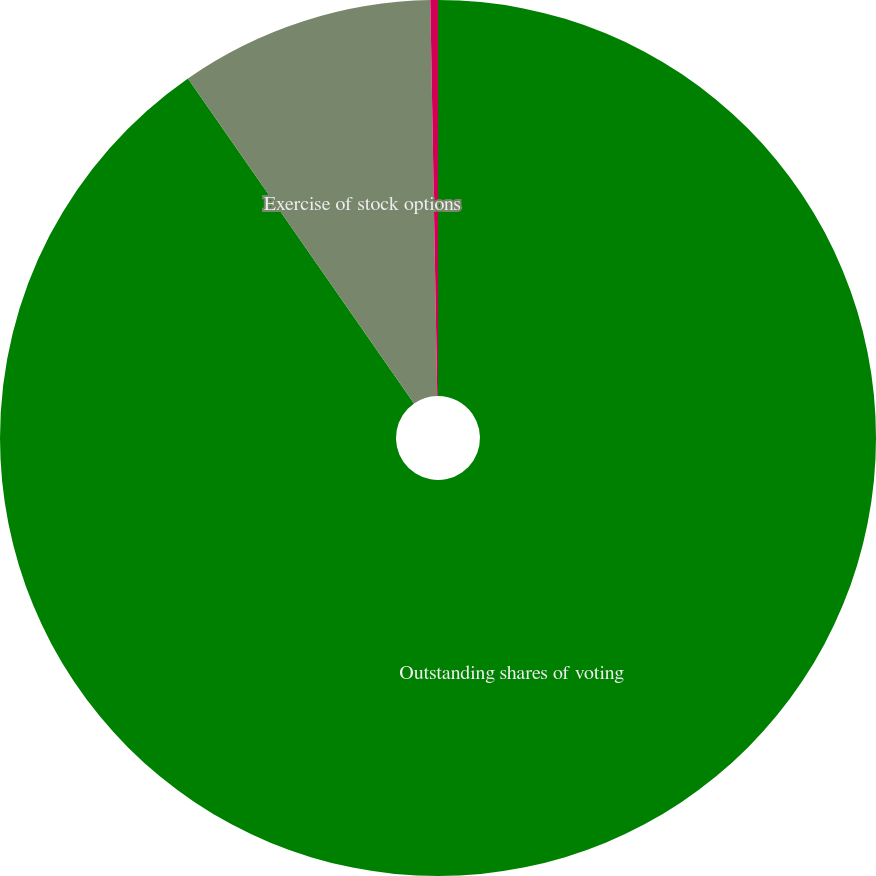Convert chart to OTSL. <chart><loc_0><loc_0><loc_500><loc_500><pie_chart><fcel>Outstanding shares of voting<fcel>Exercise of stock options<fcel>Issuance of restricted stock<nl><fcel>90.33%<fcel>9.39%<fcel>0.28%<nl></chart> 